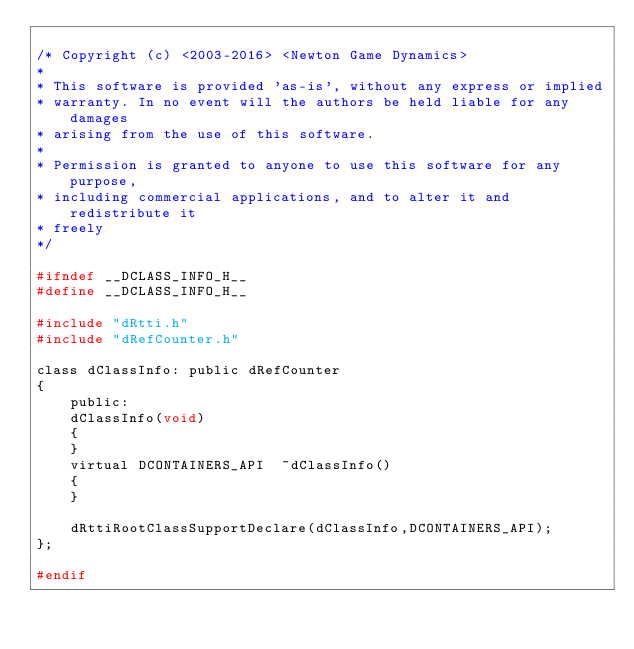<code> <loc_0><loc_0><loc_500><loc_500><_C_>
/* Copyright (c) <2003-2016> <Newton Game Dynamics>
* 
* This software is provided 'as-is', without any express or implied
* warranty. In no event will the authors be held liable for any damages
* arising from the use of this software.
* 
* Permission is granted to anyone to use this software for any purpose,
* including commercial applications, and to alter it and redistribute it
* freely
*/

#ifndef __DCLASS_INFO_H__
#define __DCLASS_INFO_H__

#include "dRtti.h"
#include "dRefCounter.h"

class dClassInfo: public dRefCounter
{
	public:
	dClassInfo(void)
	{
	}
	virtual DCONTAINERS_API  ~dClassInfo()
	{
	}

	dRttiRootClassSupportDeclare(dClassInfo,DCONTAINERS_API);
};

#endif</code> 